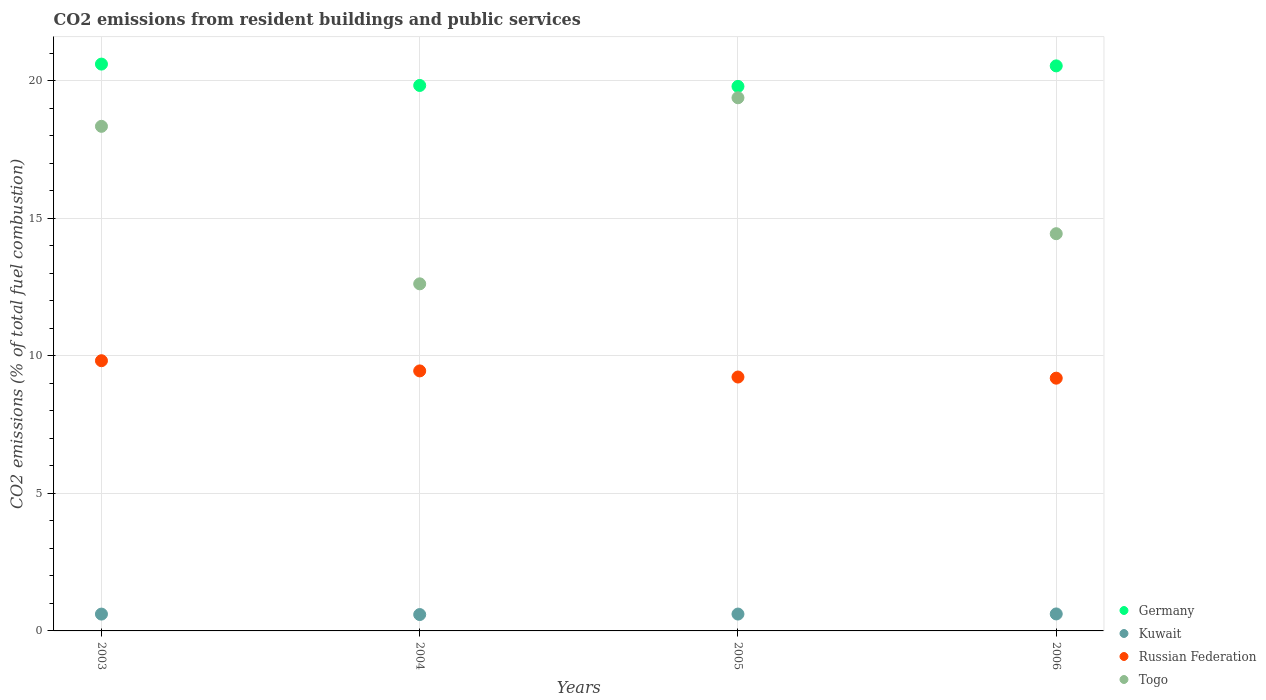How many different coloured dotlines are there?
Offer a terse response. 4. What is the total CO2 emitted in Germany in 2004?
Provide a succinct answer. 19.83. Across all years, what is the maximum total CO2 emitted in Togo?
Your answer should be very brief. 19.39. Across all years, what is the minimum total CO2 emitted in Russian Federation?
Offer a terse response. 9.19. In which year was the total CO2 emitted in Russian Federation maximum?
Make the answer very short. 2003. What is the total total CO2 emitted in Kuwait in the graph?
Give a very brief answer. 2.44. What is the difference between the total CO2 emitted in Togo in 2005 and that in 2006?
Give a very brief answer. 4.94. What is the difference between the total CO2 emitted in Togo in 2004 and the total CO2 emitted in Russian Federation in 2003?
Your answer should be compact. 2.8. What is the average total CO2 emitted in Russian Federation per year?
Provide a succinct answer. 9.43. In the year 2004, what is the difference between the total CO2 emitted in Togo and total CO2 emitted in Germany?
Provide a short and direct response. -7.21. What is the ratio of the total CO2 emitted in Germany in 2005 to that in 2006?
Ensure brevity in your answer.  0.96. What is the difference between the highest and the second highest total CO2 emitted in Kuwait?
Ensure brevity in your answer.  0. What is the difference between the highest and the lowest total CO2 emitted in Germany?
Ensure brevity in your answer.  0.81. Is the sum of the total CO2 emitted in Russian Federation in 2003 and 2005 greater than the maximum total CO2 emitted in Kuwait across all years?
Make the answer very short. Yes. Is the total CO2 emitted in Russian Federation strictly greater than the total CO2 emitted in Germany over the years?
Your response must be concise. No. Is the total CO2 emitted in Germany strictly less than the total CO2 emitted in Kuwait over the years?
Provide a short and direct response. No. What is the difference between two consecutive major ticks on the Y-axis?
Keep it short and to the point. 5. Does the graph contain grids?
Give a very brief answer. Yes. Where does the legend appear in the graph?
Give a very brief answer. Bottom right. How are the legend labels stacked?
Provide a short and direct response. Vertical. What is the title of the graph?
Ensure brevity in your answer.  CO2 emissions from resident buildings and public services. Does "Mali" appear as one of the legend labels in the graph?
Make the answer very short. No. What is the label or title of the X-axis?
Give a very brief answer. Years. What is the label or title of the Y-axis?
Make the answer very short. CO2 emissions (% of total fuel combustion). What is the CO2 emissions (% of total fuel combustion) of Germany in 2003?
Provide a succinct answer. 20.61. What is the CO2 emissions (% of total fuel combustion) in Kuwait in 2003?
Your answer should be very brief. 0.61. What is the CO2 emissions (% of total fuel combustion) in Russian Federation in 2003?
Give a very brief answer. 9.83. What is the CO2 emissions (% of total fuel combustion) in Togo in 2003?
Ensure brevity in your answer.  18.35. What is the CO2 emissions (% of total fuel combustion) in Germany in 2004?
Your answer should be very brief. 19.83. What is the CO2 emissions (% of total fuel combustion) of Kuwait in 2004?
Offer a very short reply. 0.6. What is the CO2 emissions (% of total fuel combustion) in Russian Federation in 2004?
Your answer should be compact. 9.46. What is the CO2 emissions (% of total fuel combustion) in Togo in 2004?
Offer a terse response. 12.62. What is the CO2 emissions (% of total fuel combustion) in Germany in 2005?
Offer a very short reply. 19.8. What is the CO2 emissions (% of total fuel combustion) of Kuwait in 2005?
Your answer should be very brief. 0.61. What is the CO2 emissions (% of total fuel combustion) in Russian Federation in 2005?
Provide a short and direct response. 9.23. What is the CO2 emissions (% of total fuel combustion) of Togo in 2005?
Offer a very short reply. 19.39. What is the CO2 emissions (% of total fuel combustion) of Germany in 2006?
Your answer should be very brief. 20.55. What is the CO2 emissions (% of total fuel combustion) of Kuwait in 2006?
Make the answer very short. 0.62. What is the CO2 emissions (% of total fuel combustion) of Russian Federation in 2006?
Offer a terse response. 9.19. What is the CO2 emissions (% of total fuel combustion) of Togo in 2006?
Your answer should be compact. 14.44. Across all years, what is the maximum CO2 emissions (% of total fuel combustion) of Germany?
Provide a short and direct response. 20.61. Across all years, what is the maximum CO2 emissions (% of total fuel combustion) of Kuwait?
Your answer should be very brief. 0.62. Across all years, what is the maximum CO2 emissions (% of total fuel combustion) in Russian Federation?
Provide a short and direct response. 9.83. Across all years, what is the maximum CO2 emissions (% of total fuel combustion) in Togo?
Make the answer very short. 19.39. Across all years, what is the minimum CO2 emissions (% of total fuel combustion) of Germany?
Your answer should be compact. 19.8. Across all years, what is the minimum CO2 emissions (% of total fuel combustion) of Kuwait?
Offer a terse response. 0.6. Across all years, what is the minimum CO2 emissions (% of total fuel combustion) in Russian Federation?
Make the answer very short. 9.19. Across all years, what is the minimum CO2 emissions (% of total fuel combustion) in Togo?
Your answer should be compact. 12.62. What is the total CO2 emissions (% of total fuel combustion) of Germany in the graph?
Offer a terse response. 80.79. What is the total CO2 emissions (% of total fuel combustion) of Kuwait in the graph?
Your response must be concise. 2.44. What is the total CO2 emissions (% of total fuel combustion) in Russian Federation in the graph?
Provide a succinct answer. 37.7. What is the total CO2 emissions (% of total fuel combustion) in Togo in the graph?
Give a very brief answer. 64.8. What is the difference between the CO2 emissions (% of total fuel combustion) of Germany in 2003 and that in 2004?
Offer a very short reply. 0.78. What is the difference between the CO2 emissions (% of total fuel combustion) of Kuwait in 2003 and that in 2004?
Give a very brief answer. 0.02. What is the difference between the CO2 emissions (% of total fuel combustion) in Russian Federation in 2003 and that in 2004?
Offer a very short reply. 0.37. What is the difference between the CO2 emissions (% of total fuel combustion) of Togo in 2003 and that in 2004?
Ensure brevity in your answer.  5.73. What is the difference between the CO2 emissions (% of total fuel combustion) in Germany in 2003 and that in 2005?
Offer a very short reply. 0.81. What is the difference between the CO2 emissions (% of total fuel combustion) in Kuwait in 2003 and that in 2005?
Your response must be concise. -0. What is the difference between the CO2 emissions (% of total fuel combustion) in Russian Federation in 2003 and that in 2005?
Offer a terse response. 0.59. What is the difference between the CO2 emissions (% of total fuel combustion) in Togo in 2003 and that in 2005?
Provide a succinct answer. -1.04. What is the difference between the CO2 emissions (% of total fuel combustion) of Germany in 2003 and that in 2006?
Give a very brief answer. 0.06. What is the difference between the CO2 emissions (% of total fuel combustion) of Kuwait in 2003 and that in 2006?
Keep it short and to the point. -0.01. What is the difference between the CO2 emissions (% of total fuel combustion) of Russian Federation in 2003 and that in 2006?
Offer a very short reply. 0.63. What is the difference between the CO2 emissions (% of total fuel combustion) in Togo in 2003 and that in 2006?
Provide a short and direct response. 3.9. What is the difference between the CO2 emissions (% of total fuel combustion) in Germany in 2004 and that in 2005?
Keep it short and to the point. 0.03. What is the difference between the CO2 emissions (% of total fuel combustion) in Kuwait in 2004 and that in 2005?
Keep it short and to the point. -0.02. What is the difference between the CO2 emissions (% of total fuel combustion) of Russian Federation in 2004 and that in 2005?
Your answer should be compact. 0.22. What is the difference between the CO2 emissions (% of total fuel combustion) of Togo in 2004 and that in 2005?
Offer a terse response. -6.77. What is the difference between the CO2 emissions (% of total fuel combustion) in Germany in 2004 and that in 2006?
Your answer should be compact. -0.71. What is the difference between the CO2 emissions (% of total fuel combustion) in Kuwait in 2004 and that in 2006?
Make the answer very short. -0.02. What is the difference between the CO2 emissions (% of total fuel combustion) of Russian Federation in 2004 and that in 2006?
Provide a short and direct response. 0.26. What is the difference between the CO2 emissions (% of total fuel combustion) of Togo in 2004 and that in 2006?
Your answer should be very brief. -1.82. What is the difference between the CO2 emissions (% of total fuel combustion) of Germany in 2005 and that in 2006?
Your response must be concise. -0.75. What is the difference between the CO2 emissions (% of total fuel combustion) of Kuwait in 2005 and that in 2006?
Your answer should be compact. -0. What is the difference between the CO2 emissions (% of total fuel combustion) of Russian Federation in 2005 and that in 2006?
Make the answer very short. 0.04. What is the difference between the CO2 emissions (% of total fuel combustion) in Togo in 2005 and that in 2006?
Offer a very short reply. 4.94. What is the difference between the CO2 emissions (% of total fuel combustion) in Germany in 2003 and the CO2 emissions (% of total fuel combustion) in Kuwait in 2004?
Offer a terse response. 20.02. What is the difference between the CO2 emissions (% of total fuel combustion) of Germany in 2003 and the CO2 emissions (% of total fuel combustion) of Russian Federation in 2004?
Provide a short and direct response. 11.16. What is the difference between the CO2 emissions (% of total fuel combustion) in Germany in 2003 and the CO2 emissions (% of total fuel combustion) in Togo in 2004?
Your answer should be compact. 7.99. What is the difference between the CO2 emissions (% of total fuel combustion) of Kuwait in 2003 and the CO2 emissions (% of total fuel combustion) of Russian Federation in 2004?
Give a very brief answer. -8.84. What is the difference between the CO2 emissions (% of total fuel combustion) of Kuwait in 2003 and the CO2 emissions (% of total fuel combustion) of Togo in 2004?
Offer a very short reply. -12.01. What is the difference between the CO2 emissions (% of total fuel combustion) in Russian Federation in 2003 and the CO2 emissions (% of total fuel combustion) in Togo in 2004?
Ensure brevity in your answer.  -2.8. What is the difference between the CO2 emissions (% of total fuel combustion) in Germany in 2003 and the CO2 emissions (% of total fuel combustion) in Kuwait in 2005?
Your response must be concise. 20. What is the difference between the CO2 emissions (% of total fuel combustion) in Germany in 2003 and the CO2 emissions (% of total fuel combustion) in Russian Federation in 2005?
Offer a terse response. 11.38. What is the difference between the CO2 emissions (% of total fuel combustion) in Germany in 2003 and the CO2 emissions (% of total fuel combustion) in Togo in 2005?
Ensure brevity in your answer.  1.22. What is the difference between the CO2 emissions (% of total fuel combustion) in Kuwait in 2003 and the CO2 emissions (% of total fuel combustion) in Russian Federation in 2005?
Offer a terse response. -8.62. What is the difference between the CO2 emissions (% of total fuel combustion) of Kuwait in 2003 and the CO2 emissions (% of total fuel combustion) of Togo in 2005?
Make the answer very short. -18.78. What is the difference between the CO2 emissions (% of total fuel combustion) of Russian Federation in 2003 and the CO2 emissions (% of total fuel combustion) of Togo in 2005?
Provide a short and direct response. -9.56. What is the difference between the CO2 emissions (% of total fuel combustion) of Germany in 2003 and the CO2 emissions (% of total fuel combustion) of Kuwait in 2006?
Provide a short and direct response. 19.99. What is the difference between the CO2 emissions (% of total fuel combustion) in Germany in 2003 and the CO2 emissions (% of total fuel combustion) in Russian Federation in 2006?
Your answer should be compact. 11.42. What is the difference between the CO2 emissions (% of total fuel combustion) in Germany in 2003 and the CO2 emissions (% of total fuel combustion) in Togo in 2006?
Your answer should be very brief. 6.17. What is the difference between the CO2 emissions (% of total fuel combustion) of Kuwait in 2003 and the CO2 emissions (% of total fuel combustion) of Russian Federation in 2006?
Provide a succinct answer. -8.58. What is the difference between the CO2 emissions (% of total fuel combustion) in Kuwait in 2003 and the CO2 emissions (% of total fuel combustion) in Togo in 2006?
Give a very brief answer. -13.83. What is the difference between the CO2 emissions (% of total fuel combustion) in Russian Federation in 2003 and the CO2 emissions (% of total fuel combustion) in Togo in 2006?
Offer a terse response. -4.62. What is the difference between the CO2 emissions (% of total fuel combustion) of Germany in 2004 and the CO2 emissions (% of total fuel combustion) of Kuwait in 2005?
Provide a short and direct response. 19.22. What is the difference between the CO2 emissions (% of total fuel combustion) of Germany in 2004 and the CO2 emissions (% of total fuel combustion) of Russian Federation in 2005?
Provide a short and direct response. 10.6. What is the difference between the CO2 emissions (% of total fuel combustion) of Germany in 2004 and the CO2 emissions (% of total fuel combustion) of Togo in 2005?
Your answer should be very brief. 0.45. What is the difference between the CO2 emissions (% of total fuel combustion) in Kuwait in 2004 and the CO2 emissions (% of total fuel combustion) in Russian Federation in 2005?
Offer a terse response. -8.64. What is the difference between the CO2 emissions (% of total fuel combustion) in Kuwait in 2004 and the CO2 emissions (% of total fuel combustion) in Togo in 2005?
Provide a succinct answer. -18.79. What is the difference between the CO2 emissions (% of total fuel combustion) of Russian Federation in 2004 and the CO2 emissions (% of total fuel combustion) of Togo in 2005?
Offer a very short reply. -9.93. What is the difference between the CO2 emissions (% of total fuel combustion) in Germany in 2004 and the CO2 emissions (% of total fuel combustion) in Kuwait in 2006?
Keep it short and to the point. 19.22. What is the difference between the CO2 emissions (% of total fuel combustion) of Germany in 2004 and the CO2 emissions (% of total fuel combustion) of Russian Federation in 2006?
Your answer should be very brief. 10.64. What is the difference between the CO2 emissions (% of total fuel combustion) of Germany in 2004 and the CO2 emissions (% of total fuel combustion) of Togo in 2006?
Make the answer very short. 5.39. What is the difference between the CO2 emissions (% of total fuel combustion) in Kuwait in 2004 and the CO2 emissions (% of total fuel combustion) in Russian Federation in 2006?
Ensure brevity in your answer.  -8.6. What is the difference between the CO2 emissions (% of total fuel combustion) in Kuwait in 2004 and the CO2 emissions (% of total fuel combustion) in Togo in 2006?
Offer a terse response. -13.85. What is the difference between the CO2 emissions (% of total fuel combustion) of Russian Federation in 2004 and the CO2 emissions (% of total fuel combustion) of Togo in 2006?
Your answer should be very brief. -4.99. What is the difference between the CO2 emissions (% of total fuel combustion) of Germany in 2005 and the CO2 emissions (% of total fuel combustion) of Kuwait in 2006?
Your response must be concise. 19.18. What is the difference between the CO2 emissions (% of total fuel combustion) in Germany in 2005 and the CO2 emissions (% of total fuel combustion) in Russian Federation in 2006?
Your answer should be very brief. 10.61. What is the difference between the CO2 emissions (% of total fuel combustion) of Germany in 2005 and the CO2 emissions (% of total fuel combustion) of Togo in 2006?
Your answer should be compact. 5.36. What is the difference between the CO2 emissions (% of total fuel combustion) in Kuwait in 2005 and the CO2 emissions (% of total fuel combustion) in Russian Federation in 2006?
Ensure brevity in your answer.  -8.58. What is the difference between the CO2 emissions (% of total fuel combustion) of Kuwait in 2005 and the CO2 emissions (% of total fuel combustion) of Togo in 2006?
Your answer should be compact. -13.83. What is the difference between the CO2 emissions (% of total fuel combustion) of Russian Federation in 2005 and the CO2 emissions (% of total fuel combustion) of Togo in 2006?
Provide a succinct answer. -5.21. What is the average CO2 emissions (% of total fuel combustion) in Germany per year?
Your answer should be very brief. 20.2. What is the average CO2 emissions (% of total fuel combustion) in Kuwait per year?
Keep it short and to the point. 0.61. What is the average CO2 emissions (% of total fuel combustion) of Russian Federation per year?
Give a very brief answer. 9.43. What is the average CO2 emissions (% of total fuel combustion) of Togo per year?
Offer a very short reply. 16.2. In the year 2003, what is the difference between the CO2 emissions (% of total fuel combustion) in Germany and CO2 emissions (% of total fuel combustion) in Kuwait?
Keep it short and to the point. 20. In the year 2003, what is the difference between the CO2 emissions (% of total fuel combustion) of Germany and CO2 emissions (% of total fuel combustion) of Russian Federation?
Keep it short and to the point. 10.79. In the year 2003, what is the difference between the CO2 emissions (% of total fuel combustion) in Germany and CO2 emissions (% of total fuel combustion) in Togo?
Offer a terse response. 2.26. In the year 2003, what is the difference between the CO2 emissions (% of total fuel combustion) of Kuwait and CO2 emissions (% of total fuel combustion) of Russian Federation?
Offer a terse response. -9.21. In the year 2003, what is the difference between the CO2 emissions (% of total fuel combustion) in Kuwait and CO2 emissions (% of total fuel combustion) in Togo?
Ensure brevity in your answer.  -17.74. In the year 2003, what is the difference between the CO2 emissions (% of total fuel combustion) of Russian Federation and CO2 emissions (% of total fuel combustion) of Togo?
Keep it short and to the point. -8.52. In the year 2004, what is the difference between the CO2 emissions (% of total fuel combustion) of Germany and CO2 emissions (% of total fuel combustion) of Kuwait?
Make the answer very short. 19.24. In the year 2004, what is the difference between the CO2 emissions (% of total fuel combustion) in Germany and CO2 emissions (% of total fuel combustion) in Russian Federation?
Ensure brevity in your answer.  10.38. In the year 2004, what is the difference between the CO2 emissions (% of total fuel combustion) in Germany and CO2 emissions (% of total fuel combustion) in Togo?
Your response must be concise. 7.21. In the year 2004, what is the difference between the CO2 emissions (% of total fuel combustion) of Kuwait and CO2 emissions (% of total fuel combustion) of Russian Federation?
Offer a very short reply. -8.86. In the year 2004, what is the difference between the CO2 emissions (% of total fuel combustion) of Kuwait and CO2 emissions (% of total fuel combustion) of Togo?
Provide a succinct answer. -12.03. In the year 2004, what is the difference between the CO2 emissions (% of total fuel combustion) of Russian Federation and CO2 emissions (% of total fuel combustion) of Togo?
Offer a terse response. -3.17. In the year 2005, what is the difference between the CO2 emissions (% of total fuel combustion) in Germany and CO2 emissions (% of total fuel combustion) in Kuwait?
Make the answer very short. 19.19. In the year 2005, what is the difference between the CO2 emissions (% of total fuel combustion) of Germany and CO2 emissions (% of total fuel combustion) of Russian Federation?
Provide a succinct answer. 10.57. In the year 2005, what is the difference between the CO2 emissions (% of total fuel combustion) of Germany and CO2 emissions (% of total fuel combustion) of Togo?
Make the answer very short. 0.41. In the year 2005, what is the difference between the CO2 emissions (% of total fuel combustion) of Kuwait and CO2 emissions (% of total fuel combustion) of Russian Federation?
Your answer should be compact. -8.62. In the year 2005, what is the difference between the CO2 emissions (% of total fuel combustion) in Kuwait and CO2 emissions (% of total fuel combustion) in Togo?
Ensure brevity in your answer.  -18.77. In the year 2005, what is the difference between the CO2 emissions (% of total fuel combustion) of Russian Federation and CO2 emissions (% of total fuel combustion) of Togo?
Provide a short and direct response. -10.16. In the year 2006, what is the difference between the CO2 emissions (% of total fuel combustion) of Germany and CO2 emissions (% of total fuel combustion) of Kuwait?
Give a very brief answer. 19.93. In the year 2006, what is the difference between the CO2 emissions (% of total fuel combustion) of Germany and CO2 emissions (% of total fuel combustion) of Russian Federation?
Give a very brief answer. 11.36. In the year 2006, what is the difference between the CO2 emissions (% of total fuel combustion) in Germany and CO2 emissions (% of total fuel combustion) in Togo?
Your response must be concise. 6.1. In the year 2006, what is the difference between the CO2 emissions (% of total fuel combustion) of Kuwait and CO2 emissions (% of total fuel combustion) of Russian Federation?
Make the answer very short. -8.57. In the year 2006, what is the difference between the CO2 emissions (% of total fuel combustion) of Kuwait and CO2 emissions (% of total fuel combustion) of Togo?
Provide a short and direct response. -13.83. In the year 2006, what is the difference between the CO2 emissions (% of total fuel combustion) in Russian Federation and CO2 emissions (% of total fuel combustion) in Togo?
Your answer should be very brief. -5.25. What is the ratio of the CO2 emissions (% of total fuel combustion) in Germany in 2003 to that in 2004?
Provide a short and direct response. 1.04. What is the ratio of the CO2 emissions (% of total fuel combustion) in Kuwait in 2003 to that in 2004?
Provide a short and direct response. 1.03. What is the ratio of the CO2 emissions (% of total fuel combustion) of Russian Federation in 2003 to that in 2004?
Make the answer very short. 1.04. What is the ratio of the CO2 emissions (% of total fuel combustion) of Togo in 2003 to that in 2004?
Ensure brevity in your answer.  1.45. What is the ratio of the CO2 emissions (% of total fuel combustion) in Germany in 2003 to that in 2005?
Your answer should be very brief. 1.04. What is the ratio of the CO2 emissions (% of total fuel combustion) in Russian Federation in 2003 to that in 2005?
Provide a succinct answer. 1.06. What is the ratio of the CO2 emissions (% of total fuel combustion) of Togo in 2003 to that in 2005?
Provide a succinct answer. 0.95. What is the ratio of the CO2 emissions (% of total fuel combustion) in Kuwait in 2003 to that in 2006?
Your answer should be compact. 0.99. What is the ratio of the CO2 emissions (% of total fuel combustion) of Russian Federation in 2003 to that in 2006?
Your answer should be compact. 1.07. What is the ratio of the CO2 emissions (% of total fuel combustion) in Togo in 2003 to that in 2006?
Keep it short and to the point. 1.27. What is the ratio of the CO2 emissions (% of total fuel combustion) in Kuwait in 2004 to that in 2005?
Your answer should be very brief. 0.97. What is the ratio of the CO2 emissions (% of total fuel combustion) of Russian Federation in 2004 to that in 2005?
Provide a succinct answer. 1.02. What is the ratio of the CO2 emissions (% of total fuel combustion) in Togo in 2004 to that in 2005?
Your answer should be compact. 0.65. What is the ratio of the CO2 emissions (% of total fuel combustion) of Germany in 2004 to that in 2006?
Keep it short and to the point. 0.97. What is the ratio of the CO2 emissions (% of total fuel combustion) of Kuwait in 2004 to that in 2006?
Ensure brevity in your answer.  0.96. What is the ratio of the CO2 emissions (% of total fuel combustion) in Russian Federation in 2004 to that in 2006?
Provide a succinct answer. 1.03. What is the ratio of the CO2 emissions (% of total fuel combustion) of Togo in 2004 to that in 2006?
Offer a very short reply. 0.87. What is the ratio of the CO2 emissions (% of total fuel combustion) of Germany in 2005 to that in 2006?
Your response must be concise. 0.96. What is the ratio of the CO2 emissions (% of total fuel combustion) of Togo in 2005 to that in 2006?
Provide a short and direct response. 1.34. What is the difference between the highest and the second highest CO2 emissions (% of total fuel combustion) in Germany?
Keep it short and to the point. 0.06. What is the difference between the highest and the second highest CO2 emissions (% of total fuel combustion) in Kuwait?
Your response must be concise. 0. What is the difference between the highest and the second highest CO2 emissions (% of total fuel combustion) of Russian Federation?
Offer a very short reply. 0.37. What is the difference between the highest and the second highest CO2 emissions (% of total fuel combustion) of Togo?
Your answer should be very brief. 1.04. What is the difference between the highest and the lowest CO2 emissions (% of total fuel combustion) of Germany?
Your response must be concise. 0.81. What is the difference between the highest and the lowest CO2 emissions (% of total fuel combustion) of Kuwait?
Provide a succinct answer. 0.02. What is the difference between the highest and the lowest CO2 emissions (% of total fuel combustion) of Russian Federation?
Your answer should be compact. 0.63. What is the difference between the highest and the lowest CO2 emissions (% of total fuel combustion) in Togo?
Offer a terse response. 6.77. 